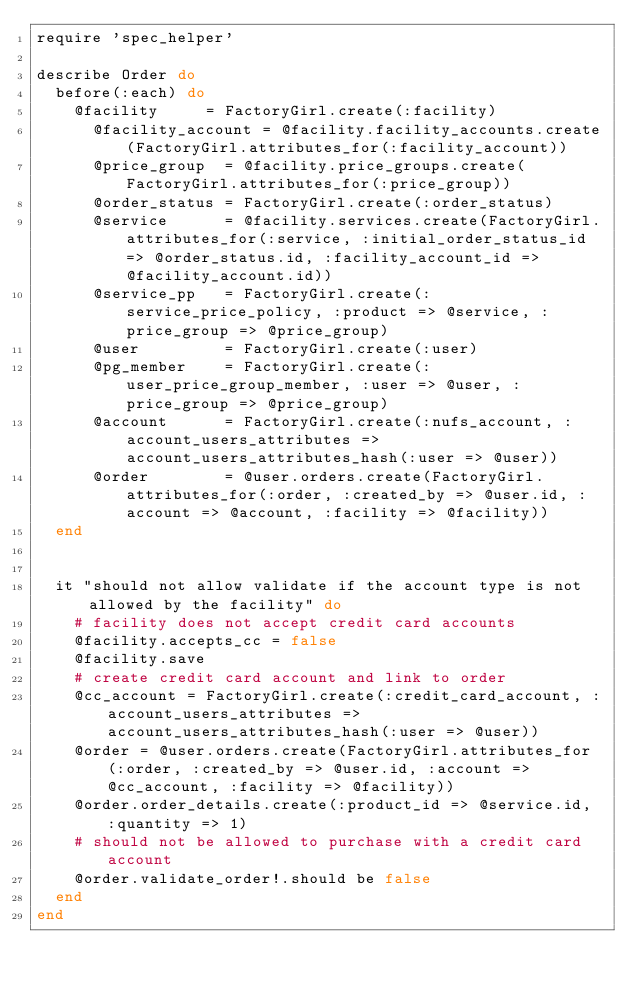<code> <loc_0><loc_0><loc_500><loc_500><_Ruby_>require 'spec_helper'

describe Order do
  before(:each) do
    @facility     = FactoryGirl.create(:facility)
      @facility_account = @facility.facility_accounts.create(FactoryGirl.attributes_for(:facility_account))
      @price_group  = @facility.price_groups.create(FactoryGirl.attributes_for(:price_group))
      @order_status = FactoryGirl.create(:order_status)
      @service      = @facility.services.create(FactoryGirl.attributes_for(:service, :initial_order_status_id => @order_status.id, :facility_account_id => @facility_account.id))
      @service_pp   = FactoryGirl.create(:service_price_policy, :product => @service, :price_group => @price_group)
      @user         = FactoryGirl.create(:user)
      @pg_member    = FactoryGirl.create(:user_price_group_member, :user => @user, :price_group => @price_group)
      @account      = FactoryGirl.create(:nufs_account, :account_users_attributes => account_users_attributes_hash(:user => @user))
      @order        = @user.orders.create(FactoryGirl.attributes_for(:order, :created_by => @user.id, :account => @account, :facility => @facility))
  end


  it "should not allow validate if the account type is not allowed by the facility" do
    # facility does not accept credit card accounts
    @facility.accepts_cc = false
    @facility.save
    # create credit card account and link to order
    @cc_account = FactoryGirl.create(:credit_card_account, :account_users_attributes => account_users_attributes_hash(:user => @user))
    @order = @user.orders.create(FactoryGirl.attributes_for(:order, :created_by => @user.id, :account => @cc_account, :facility => @facility))
    @order.order_details.create(:product_id => @service.id, :quantity => 1)
    # should not be allowed to purchase with a credit card account
    @order.validate_order!.should be false
  end
end</code> 